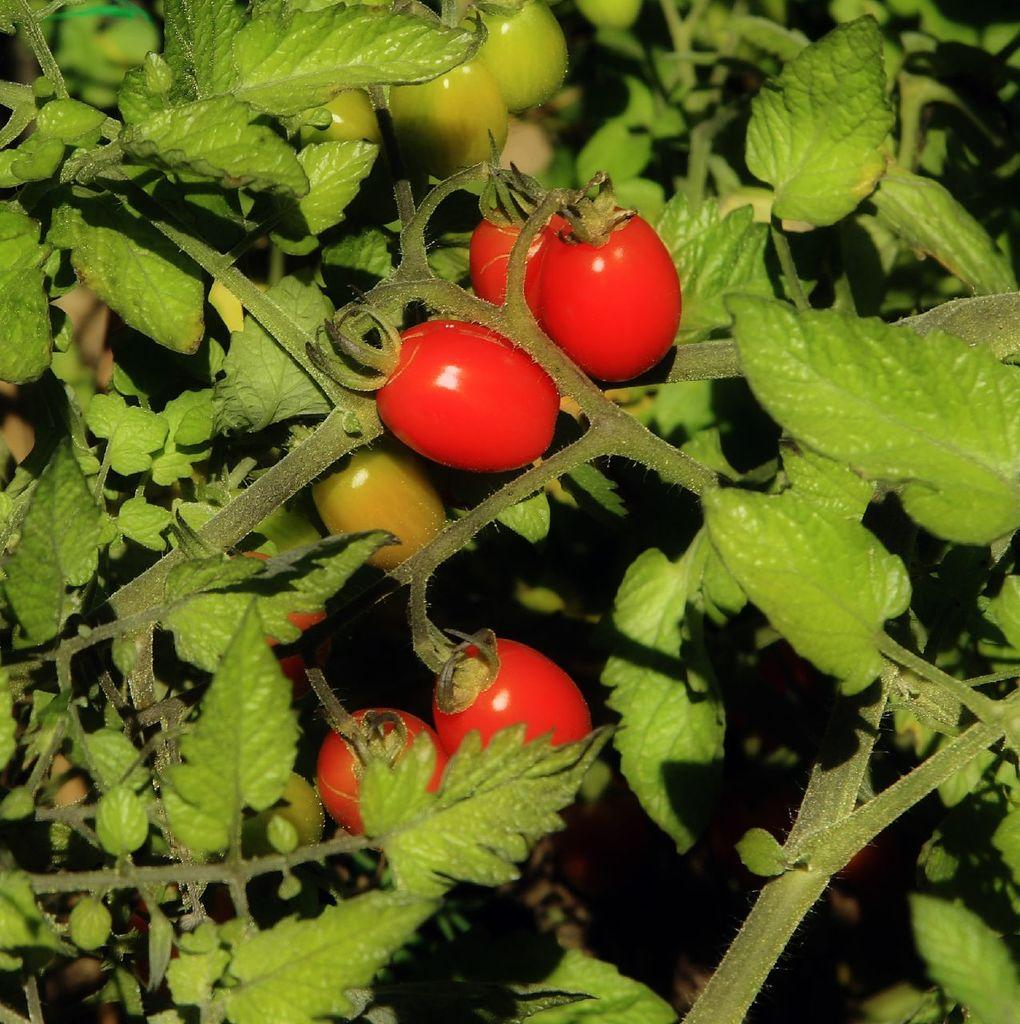What type of plants are in the image? There are tomato plants in the image. What can be found on the tomato plants? There are tomatoes in the image. What type of prose is being recited on the stage in the image? There is no stage or prose present in the image; it features tomato plants and tomatoes. Can you describe the bee pollinating the tomato plants in the image? There are no bees present in the image; it only shows tomato plants and tomatoes. 